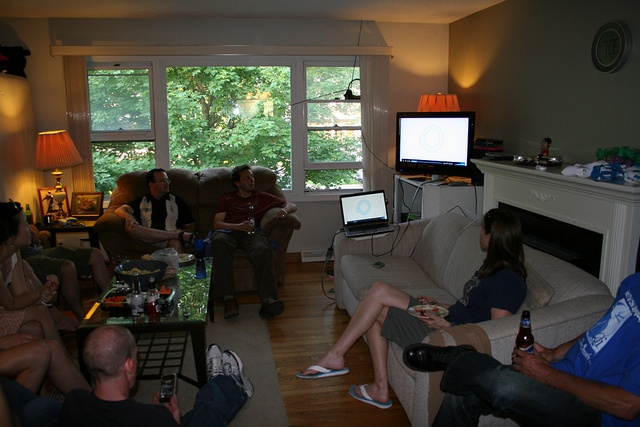Describe the objects in this image and their specific colors. I can see couch in maroon, gray, and black tones, people in maroon, black, navy, and gray tones, people in maroon, black, and gray tones, people in maroon, black, gray, and brown tones, and couch in maroon, black, gray, and darkgray tones in this image. 